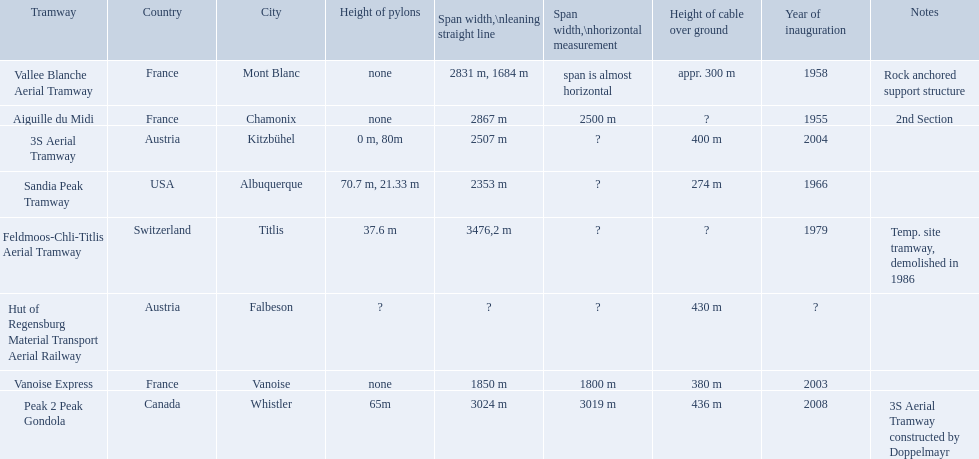Which tramways are in france? Vanoise Express, Aiguille du Midi, Vallee Blanche Aerial Tramway. Which of those were inaugurated in the 1950? Aiguille du Midi, Vallee Blanche Aerial Tramway. I'm looking to parse the entire table for insights. Could you assist me with that? {'header': ['Tramway', 'Country', 'City', 'Height of pylons', 'Span\xa0width,\\nleaning straight line', 'Span width,\\nhorizontal measurement', 'Height of cable over ground', 'Year of inauguration', 'Notes'], 'rows': [['Vallee Blanche Aerial Tramway', 'France', 'Mont Blanc', 'none', '2831 m, 1684 m', 'span is almost horizontal', 'appr. 300 m', '1958', 'Rock anchored support structure'], ['Aiguille du Midi', 'France', 'Chamonix', 'none', '2867 m', '2500 m', '?', '1955', '2nd Section'], ['3S Aerial Tramway', 'Austria', 'Kitzbühel', '0 m, 80m', '2507 m', '?', '400 m', '2004', ''], ['Sandia Peak Tramway', 'USA', 'Albuquerque', '70.7 m, 21.33 m', '2353 m', '?', '274 m', '1966', ''], ['Feldmoos-Chli-Titlis Aerial Tramway', 'Switzerland', 'Titlis', '37.6 m', '3476,2 m', '?', '?', '1979', 'Temp. site tramway, demolished in 1986'], ['Hut of Regensburg Material Transport Aerial Railway', 'Austria', 'Falbeson', '?', '?', '?', '430 m', '?', ''], ['Vanoise Express', 'France', 'Vanoise', 'none', '1850 m', '1800 m', '380 m', '2003', ''], ['Peak 2 Peak Gondola', 'Canada', 'Whistler', '65m', '3024 m', '3019 m', '436 m', '2008', '3S Aerial Tramway constructed by Doppelmayr']]} Which of these tramways span is not almost horizontal? Aiguille du Midi. 